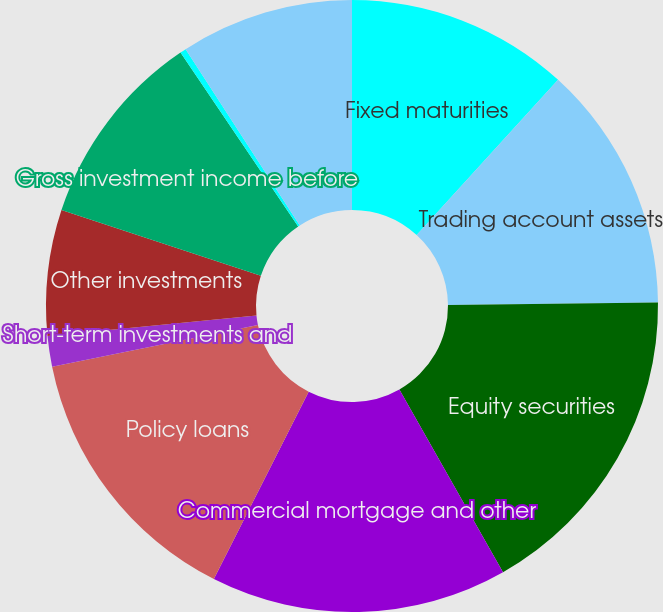Convert chart. <chart><loc_0><loc_0><loc_500><loc_500><pie_chart><fcel>Fixed maturities<fcel>Trading account assets<fcel>Equity securities<fcel>Commercial mortgage and other<fcel>Policy loans<fcel>Short-term investments and<fcel>Other investments<fcel>Gross investment income before<fcel>Investment expenses<fcel>Investment income after<nl><fcel>11.76%<fcel>13.06%<fcel>16.97%<fcel>15.67%<fcel>14.36%<fcel>1.62%<fcel>6.65%<fcel>10.45%<fcel>0.32%<fcel>9.15%<nl></chart> 